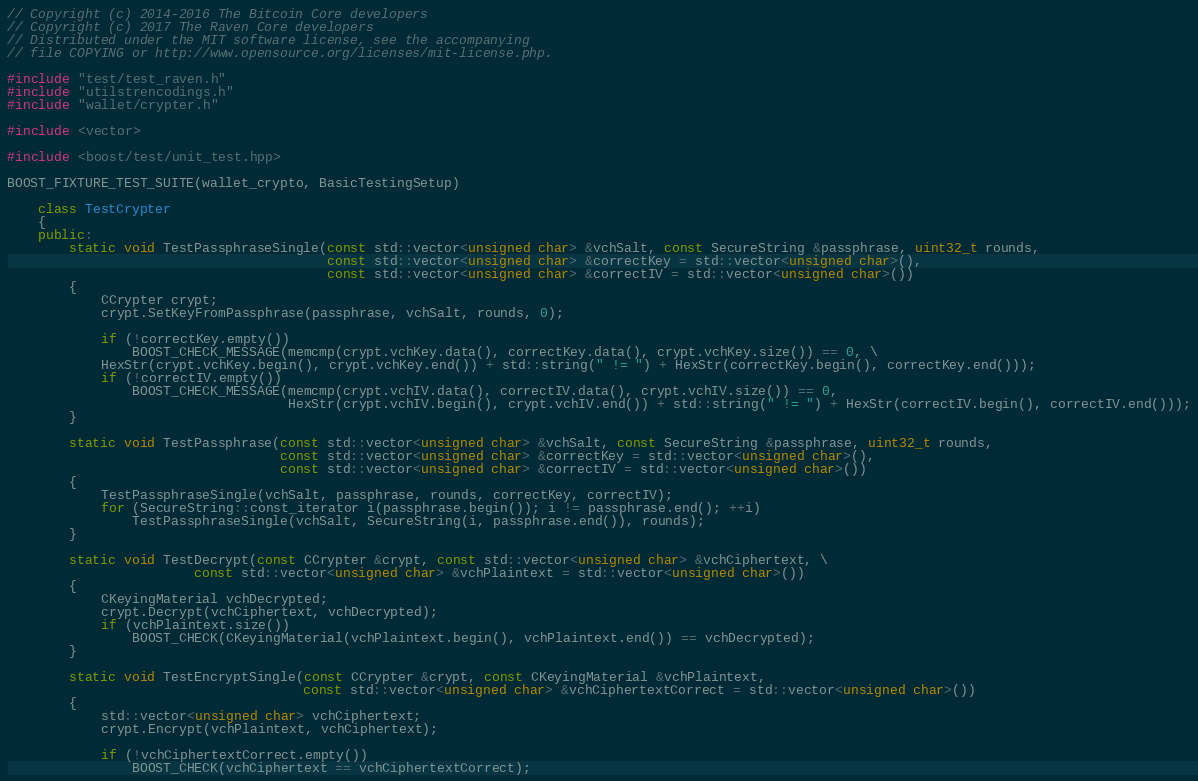<code> <loc_0><loc_0><loc_500><loc_500><_C++_>// Copyright (c) 2014-2016 The Bitcoin Core developers
// Copyright (c) 2017 The Raven Core developers
// Distributed under the MIT software license, see the accompanying
// file COPYING or http://www.opensource.org/licenses/mit-license.php.

#include "test/test_raven.h"
#include "utilstrencodings.h"
#include "wallet/crypter.h"

#include <vector>

#include <boost/test/unit_test.hpp>

BOOST_FIXTURE_TEST_SUITE(wallet_crypto, BasicTestingSetup)

    class TestCrypter
    {
    public:
        static void TestPassphraseSingle(const std::vector<unsigned char> &vchSalt, const SecureString &passphrase, uint32_t rounds,
                                         const std::vector<unsigned char> &correctKey = std::vector<unsigned char>(),
                                         const std::vector<unsigned char> &correctIV = std::vector<unsigned char>())
        {
            CCrypter crypt;
            crypt.SetKeyFromPassphrase(passphrase, vchSalt, rounds, 0);

            if (!correctKey.empty())
                BOOST_CHECK_MESSAGE(memcmp(crypt.vchKey.data(), correctKey.data(), crypt.vchKey.size()) == 0, \
            HexStr(crypt.vchKey.begin(), crypt.vchKey.end()) + std::string(" != ") + HexStr(correctKey.begin(), correctKey.end()));
            if (!correctIV.empty())
                BOOST_CHECK_MESSAGE(memcmp(crypt.vchIV.data(), correctIV.data(), crypt.vchIV.size()) == 0,
                                    HexStr(crypt.vchIV.begin(), crypt.vchIV.end()) + std::string(" != ") + HexStr(correctIV.begin(), correctIV.end()));
        }

        static void TestPassphrase(const std::vector<unsigned char> &vchSalt, const SecureString &passphrase, uint32_t rounds,
                                   const std::vector<unsigned char> &correctKey = std::vector<unsigned char>(),
                                   const std::vector<unsigned char> &correctIV = std::vector<unsigned char>())
        {
            TestPassphraseSingle(vchSalt, passphrase, rounds, correctKey, correctIV);
            for (SecureString::const_iterator i(passphrase.begin()); i != passphrase.end(); ++i)
                TestPassphraseSingle(vchSalt, SecureString(i, passphrase.end()), rounds);
        }

        static void TestDecrypt(const CCrypter &crypt, const std::vector<unsigned char> &vchCiphertext, \
                        const std::vector<unsigned char> &vchPlaintext = std::vector<unsigned char>())
        {
            CKeyingMaterial vchDecrypted;
            crypt.Decrypt(vchCiphertext, vchDecrypted);
            if (vchPlaintext.size())
                BOOST_CHECK(CKeyingMaterial(vchPlaintext.begin(), vchPlaintext.end()) == vchDecrypted);
        }

        static void TestEncryptSingle(const CCrypter &crypt, const CKeyingMaterial &vchPlaintext,
                                      const std::vector<unsigned char> &vchCiphertextCorrect = std::vector<unsigned char>())
        {
            std::vector<unsigned char> vchCiphertext;
            crypt.Encrypt(vchPlaintext, vchCiphertext);

            if (!vchCiphertextCorrect.empty())
                BOOST_CHECK(vchCiphertext == vchCiphertextCorrect);
</code> 